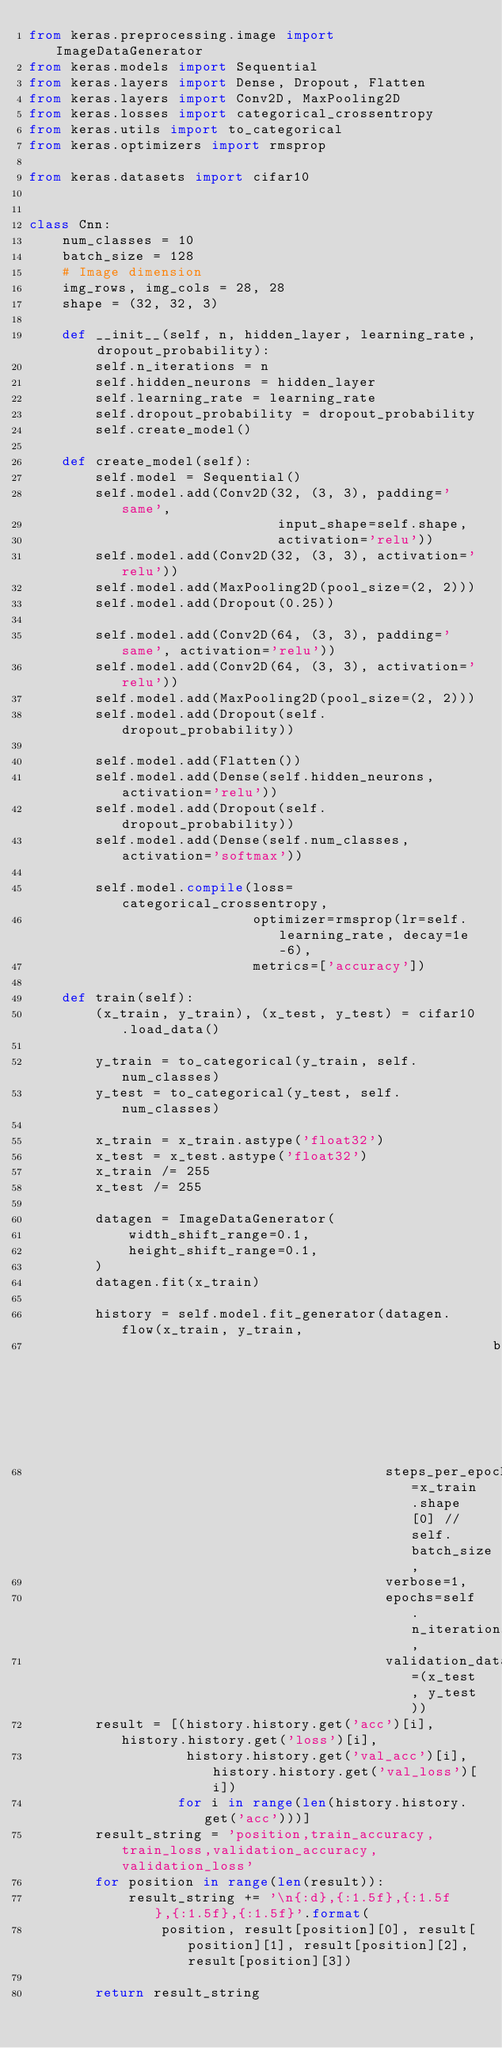<code> <loc_0><loc_0><loc_500><loc_500><_Python_>from keras.preprocessing.image import ImageDataGenerator
from keras.models import Sequential
from keras.layers import Dense, Dropout, Flatten
from keras.layers import Conv2D, MaxPooling2D
from keras.losses import categorical_crossentropy
from keras.utils import to_categorical
from keras.optimizers import rmsprop

from keras.datasets import cifar10


class Cnn:
    num_classes = 10
    batch_size = 128
    # Image dimension
    img_rows, img_cols = 28, 28
    shape = (32, 32, 3)

    def __init__(self, n, hidden_layer, learning_rate, dropout_probability):
        self.n_iterations = n
        self.hidden_neurons = hidden_layer
        self.learning_rate = learning_rate
        self.dropout_probability = dropout_probability
        self.create_model()

    def create_model(self):
        self.model = Sequential()
        self.model.add(Conv2D(32, (3, 3), padding='same',
                              input_shape=self.shape,
                              activation='relu'))
        self.model.add(Conv2D(32, (3, 3), activation='relu'))
        self.model.add(MaxPooling2D(pool_size=(2, 2)))
        self.model.add(Dropout(0.25))

        self.model.add(Conv2D(64, (3, 3), padding='same', activation='relu'))
        self.model.add(Conv2D(64, (3, 3), activation='relu'))
        self.model.add(MaxPooling2D(pool_size=(2, 2)))
        self.model.add(Dropout(self.dropout_probability))

        self.model.add(Flatten())
        self.model.add(Dense(self.hidden_neurons, activation='relu'))
        self.model.add(Dropout(self.dropout_probability))
        self.model.add(Dense(self.num_classes, activation='softmax'))

        self.model.compile(loss=categorical_crossentropy,
                           optimizer=rmsprop(lr=self.learning_rate, decay=1e-6),
                           metrics=['accuracy'])

    def train(self):
        (x_train, y_train), (x_test, y_test) = cifar10.load_data()

        y_train = to_categorical(y_train, self.num_classes)
        y_test = to_categorical(y_test, self.num_classes)

        x_train = x_train.astype('float32')
        x_test = x_test.astype('float32')
        x_train /= 255
        x_test /= 255

        datagen = ImageDataGenerator(
            width_shift_range=0.1,
            height_shift_range=0.1,
        )
        datagen.fit(x_train)

        history = self.model.fit_generator(datagen.flow(x_train, y_train,
                                                        batch_size=self.batch_size),
                                           steps_per_epoch=x_train.shape[0] // self.batch_size,
                                           verbose=1,
                                           epochs=self.n_iterations,
                                           validation_data=(x_test, y_test))
        result = [(history.history.get('acc')[i], history.history.get('loss')[i],
                   history.history.get('val_acc')[i], history.history.get('val_loss')[i])
                  for i in range(len(history.history.get('acc')))]
        result_string = 'position,train_accuracy,train_loss,validation_accuracy,validation_loss'
        for position in range(len(result)):
            result_string += '\n{:d},{:1.5f},{:1.5f},{:1.5f},{:1.5f}'.format(
                position, result[position][0], result[position][1], result[position][2], result[position][3])

        return result_string
</code> 